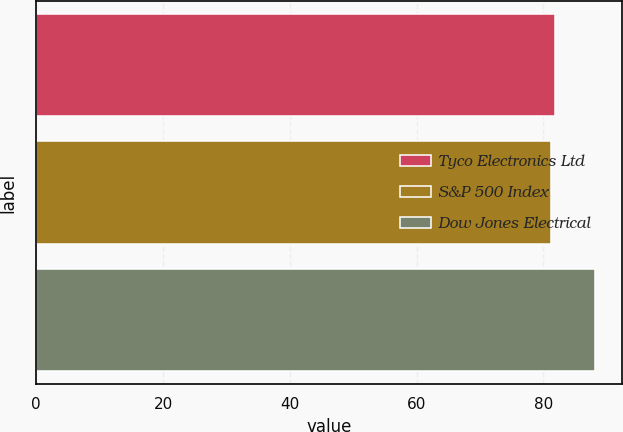Convert chart. <chart><loc_0><loc_0><loc_500><loc_500><bar_chart><fcel>Tyco Electronics Ltd<fcel>S&P 500 Index<fcel>Dow Jones Electrical<nl><fcel>81.82<fcel>81.13<fcel>88.07<nl></chart> 